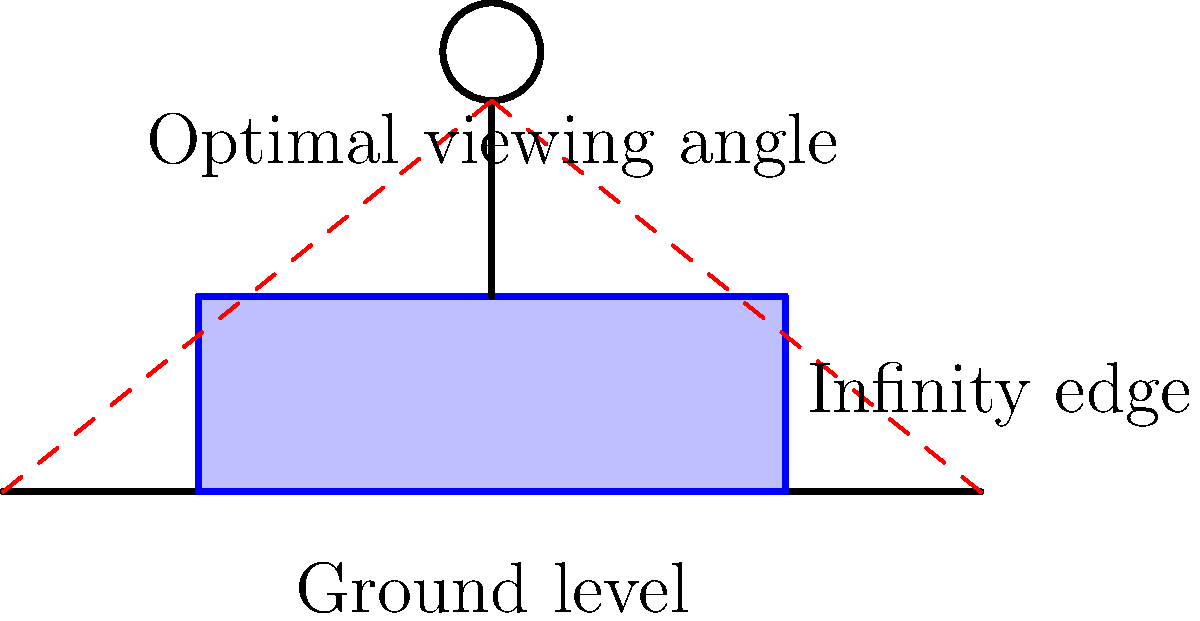Per massimizzare l'effetto visivo di una piscina a sfioro personalizzata in una proprietà di lusso, qual è l'angolo di visione ottimale, rispetto all'orizzonte, per un osservatore in piedi al bordo della piscina? Per determinare l'angolo di visione ottimale per una piscina a sfioro, consideriamo i seguenti passaggi:

1. La biomeccanica umana suggerisce che l'angolo di visione più confortevole per gli occhi è leggermente inclinato verso il basso, circa 15-20 gradi sotto l'orizzonte.

2. Questo angolo consente una visione rilassata senza sforzare i muscoli del collo o degli occhi.

3. Per una piscina a sfioro, vogliamo che l'osservatore possa vedere facilmente l'effetto "infinito" dove l'acqua sembra fondersi con l'orizzonte.

4. L'altezza media di un adulto è di circa 1,7 metri, e gli occhi sono posizionati circa 10 cm più in basso.

5. Considerando che l'osservatore è in piedi al bordo della piscina, l'altezza degli occhi dal livello dell'acqua sarà di circa 1,6 metri.

6. Utilizzando la trigonometria, possiamo calcolare l'angolo ottimale:
   $\tan(\theta) = \frac{\text{altezza occhi}}{\text{distanza orizzonte}}$

7. Assumendo una distanza all'orizzonte di circa 5 km (visibile in condizioni ideali), abbiamo:
   $\tan(\theta) = \frac{1.6}{5000} \approx 0.00032$

8. Calcolando l'arcotangente, otteniamo:
   $\theta = \arctan(0.00032) \approx 0.018 \text{ radianti} \approx 1.03°$

9. Questo angolo è molto piccolo e potrebbe non fornire l'effetto desiderato. Per migliorare l'esperienza visiva, possiamo considerare un angolo leggermente maggiore, intorno ai 15-20 gradi, che corrisponde all'angolo di visione confortevole menzionato prima.

Quindi, l'angolo di visione ottimale per massimizzare l'effetto della piscina a sfioro, bilanciando comfort visivo e impatto estetico, sarà di circa 15-20 gradi sotto l'orizzonte.
Answer: 15-20 gradi sotto l'orizzonte 